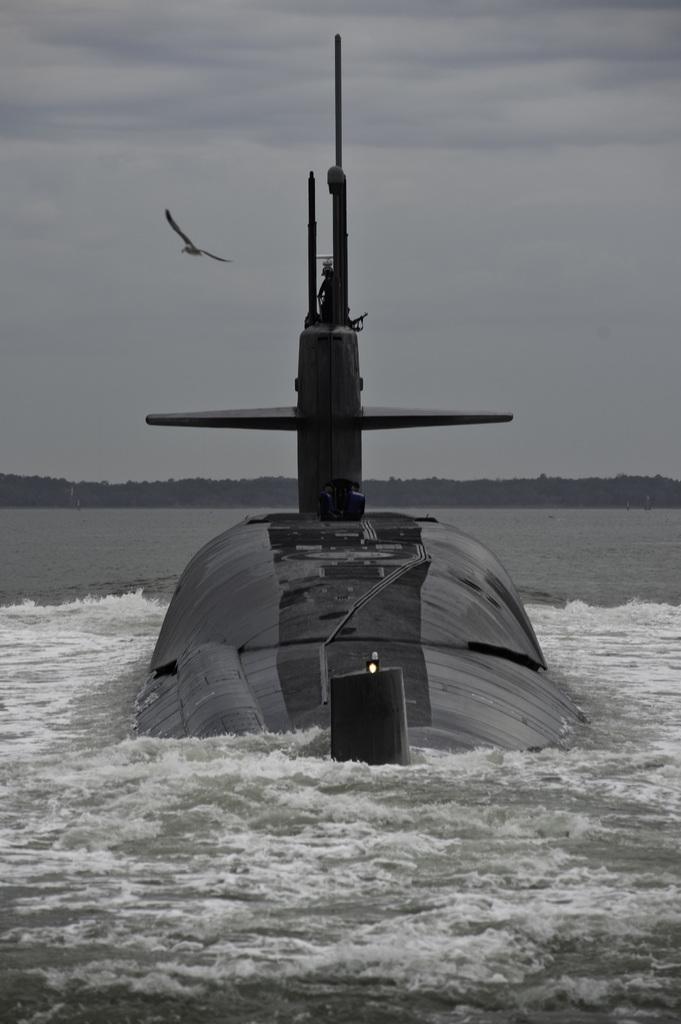Please provide a concise description of this image. This is a black and white image. In this image I can see a boat in the water. In the background there are trees. On the left side there is a bird flying in the air. At the top of the image I can see the sky. 